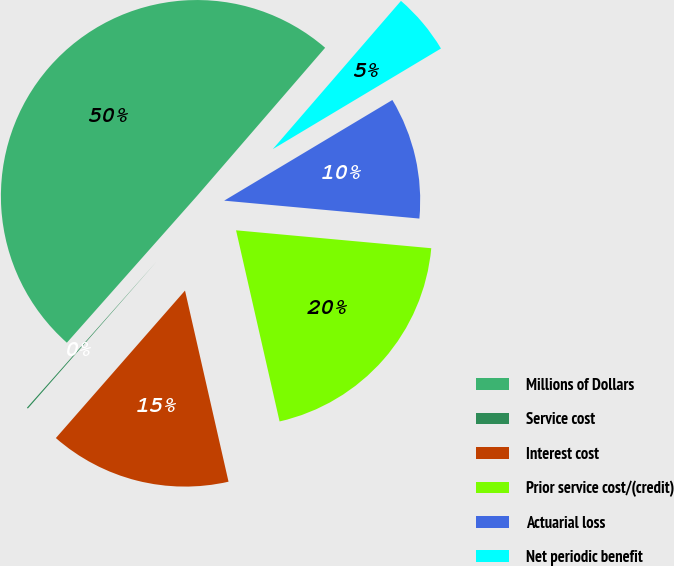<chart> <loc_0><loc_0><loc_500><loc_500><pie_chart><fcel>Millions of Dollars<fcel>Service cost<fcel>Interest cost<fcel>Prior service cost/(credit)<fcel>Actuarial loss<fcel>Net periodic benefit<nl><fcel>49.8%<fcel>0.1%<fcel>15.01%<fcel>19.98%<fcel>10.04%<fcel>5.07%<nl></chart> 